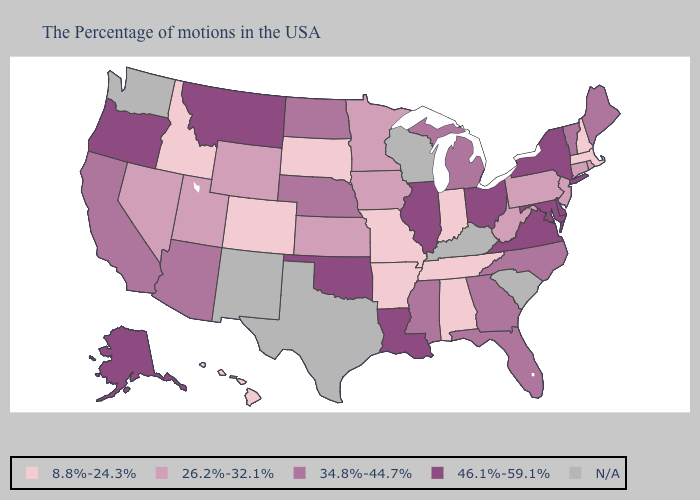Does Arkansas have the lowest value in the USA?
Quick response, please. Yes. Among the states that border North Dakota , does South Dakota have the lowest value?
Short answer required. Yes. Which states have the lowest value in the MidWest?
Concise answer only. Indiana, Missouri, South Dakota. Does the map have missing data?
Write a very short answer. Yes. Name the states that have a value in the range 34.8%-44.7%?
Be succinct. Maine, Vermont, North Carolina, Florida, Georgia, Michigan, Mississippi, Nebraska, North Dakota, Arizona, California. What is the value of Minnesota?
Answer briefly. 26.2%-32.1%. Is the legend a continuous bar?
Quick response, please. No. What is the highest value in states that border New Mexico?
Be succinct. 46.1%-59.1%. Does Indiana have the lowest value in the USA?
Short answer required. Yes. Among the states that border Connecticut , which have the lowest value?
Be succinct. Massachusetts. Name the states that have a value in the range 26.2%-32.1%?
Keep it brief. Rhode Island, Connecticut, New Jersey, Pennsylvania, West Virginia, Minnesota, Iowa, Kansas, Wyoming, Utah, Nevada. Among the states that border Delaware , does Maryland have the lowest value?
Keep it brief. No. What is the value of Iowa?
Quick response, please. 26.2%-32.1%. 